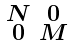Convert formula to latex. <formula><loc_0><loc_0><loc_500><loc_500>\begin{smallmatrix} N & 0 \\ 0 & M \end{smallmatrix}</formula> 